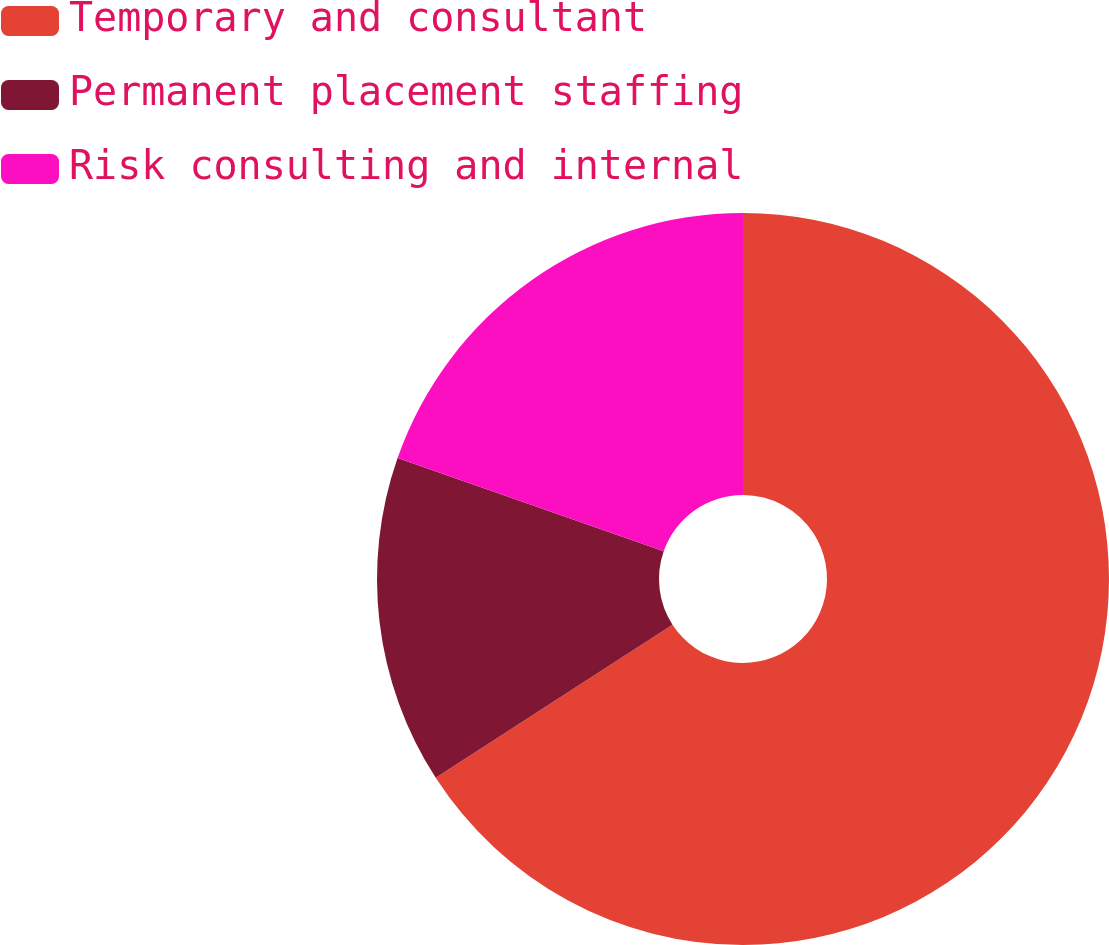Convert chart. <chart><loc_0><loc_0><loc_500><loc_500><pie_chart><fcel>Temporary and consultant<fcel>Permanent placement staffing<fcel>Risk consulting and internal<nl><fcel>65.86%<fcel>14.5%<fcel>19.64%<nl></chart> 